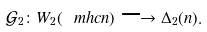<formula> <loc_0><loc_0><loc_500><loc_500>\mathcal { G } _ { 2 } \colon W _ { 2 } ( \ m h c n ) \longrightarrow \Delta _ { 2 } ( n ) .</formula> 